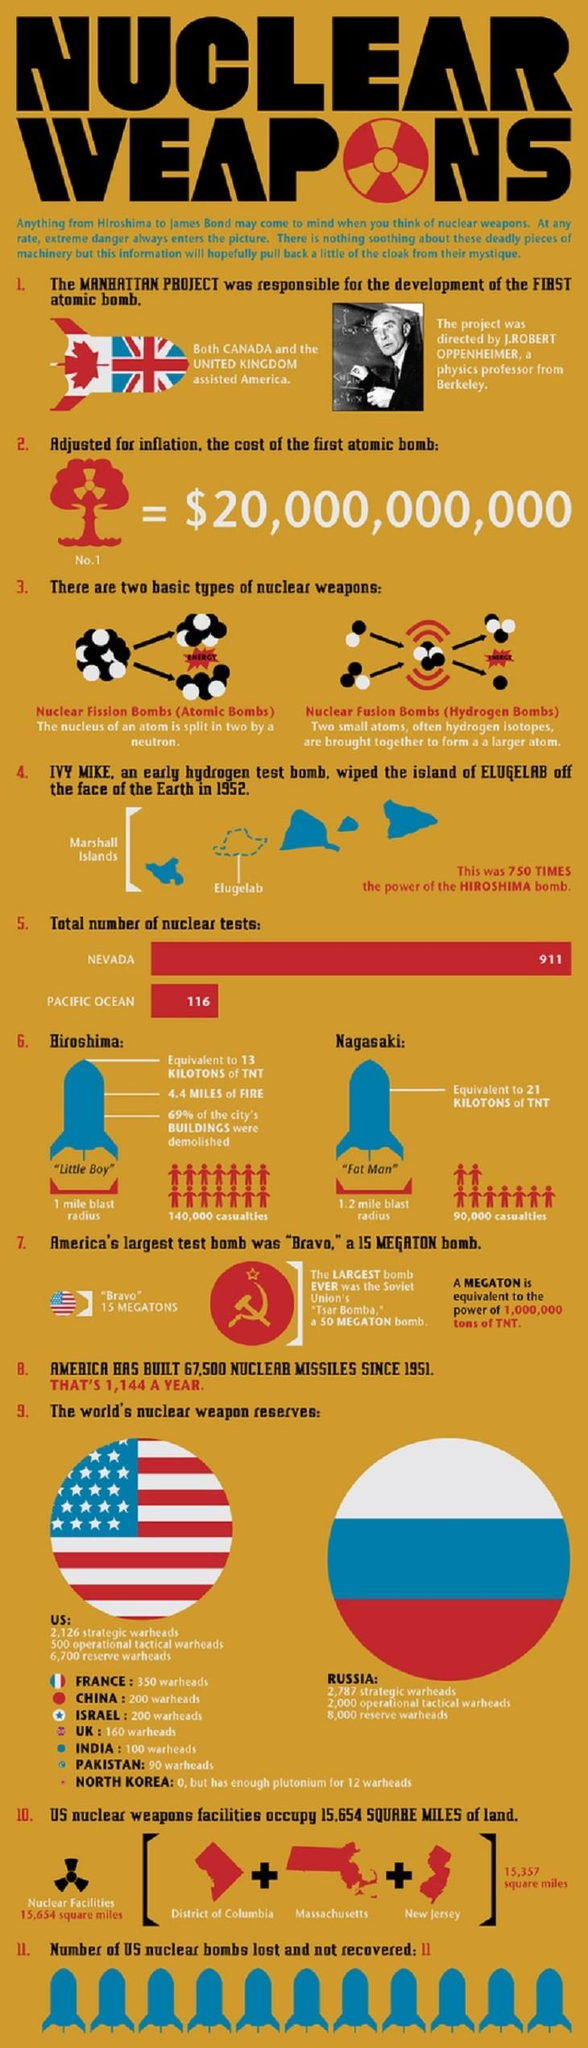Draw attention to some important aspects in this diagram. Russia has the largest number of nuclear weapon reserves in the world. J. Robert Oppenheimer was the individual who held leadership responsibilities for the Manhattan Project. The United States is the country with the second-largest number of nuclear weapon reserves in the world. The Tsar Bomba is widely regarded as the most powerful nuclear bomb in history. The atomic bomb dropped on Nagasaki, code-named "Fat Man," remains a significant and tragic event in the history of humanity. 